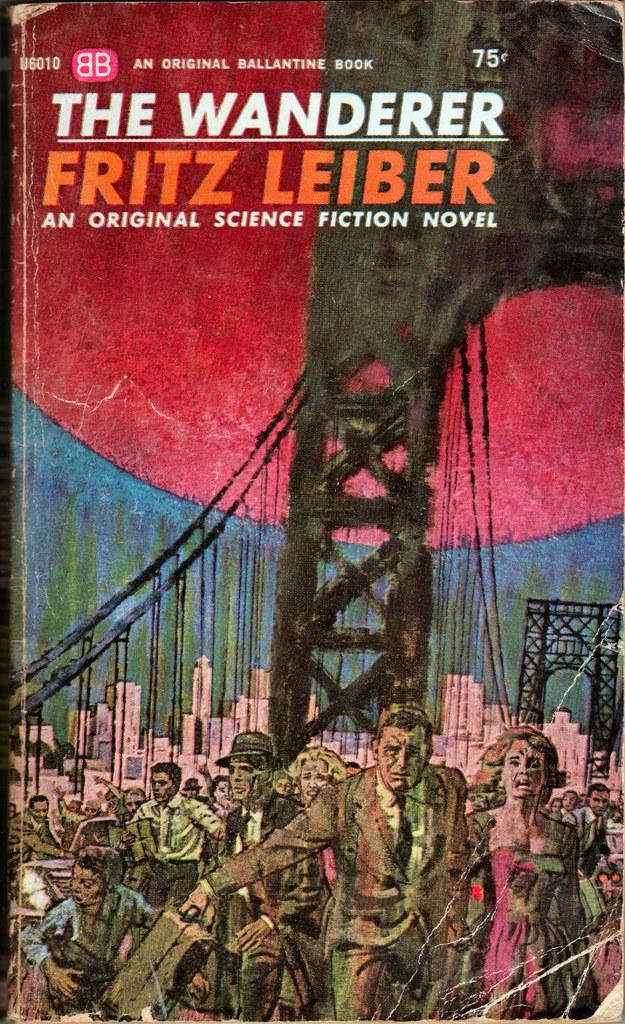Who wrote this book?
Ensure brevity in your answer.  Fritz leiber. 